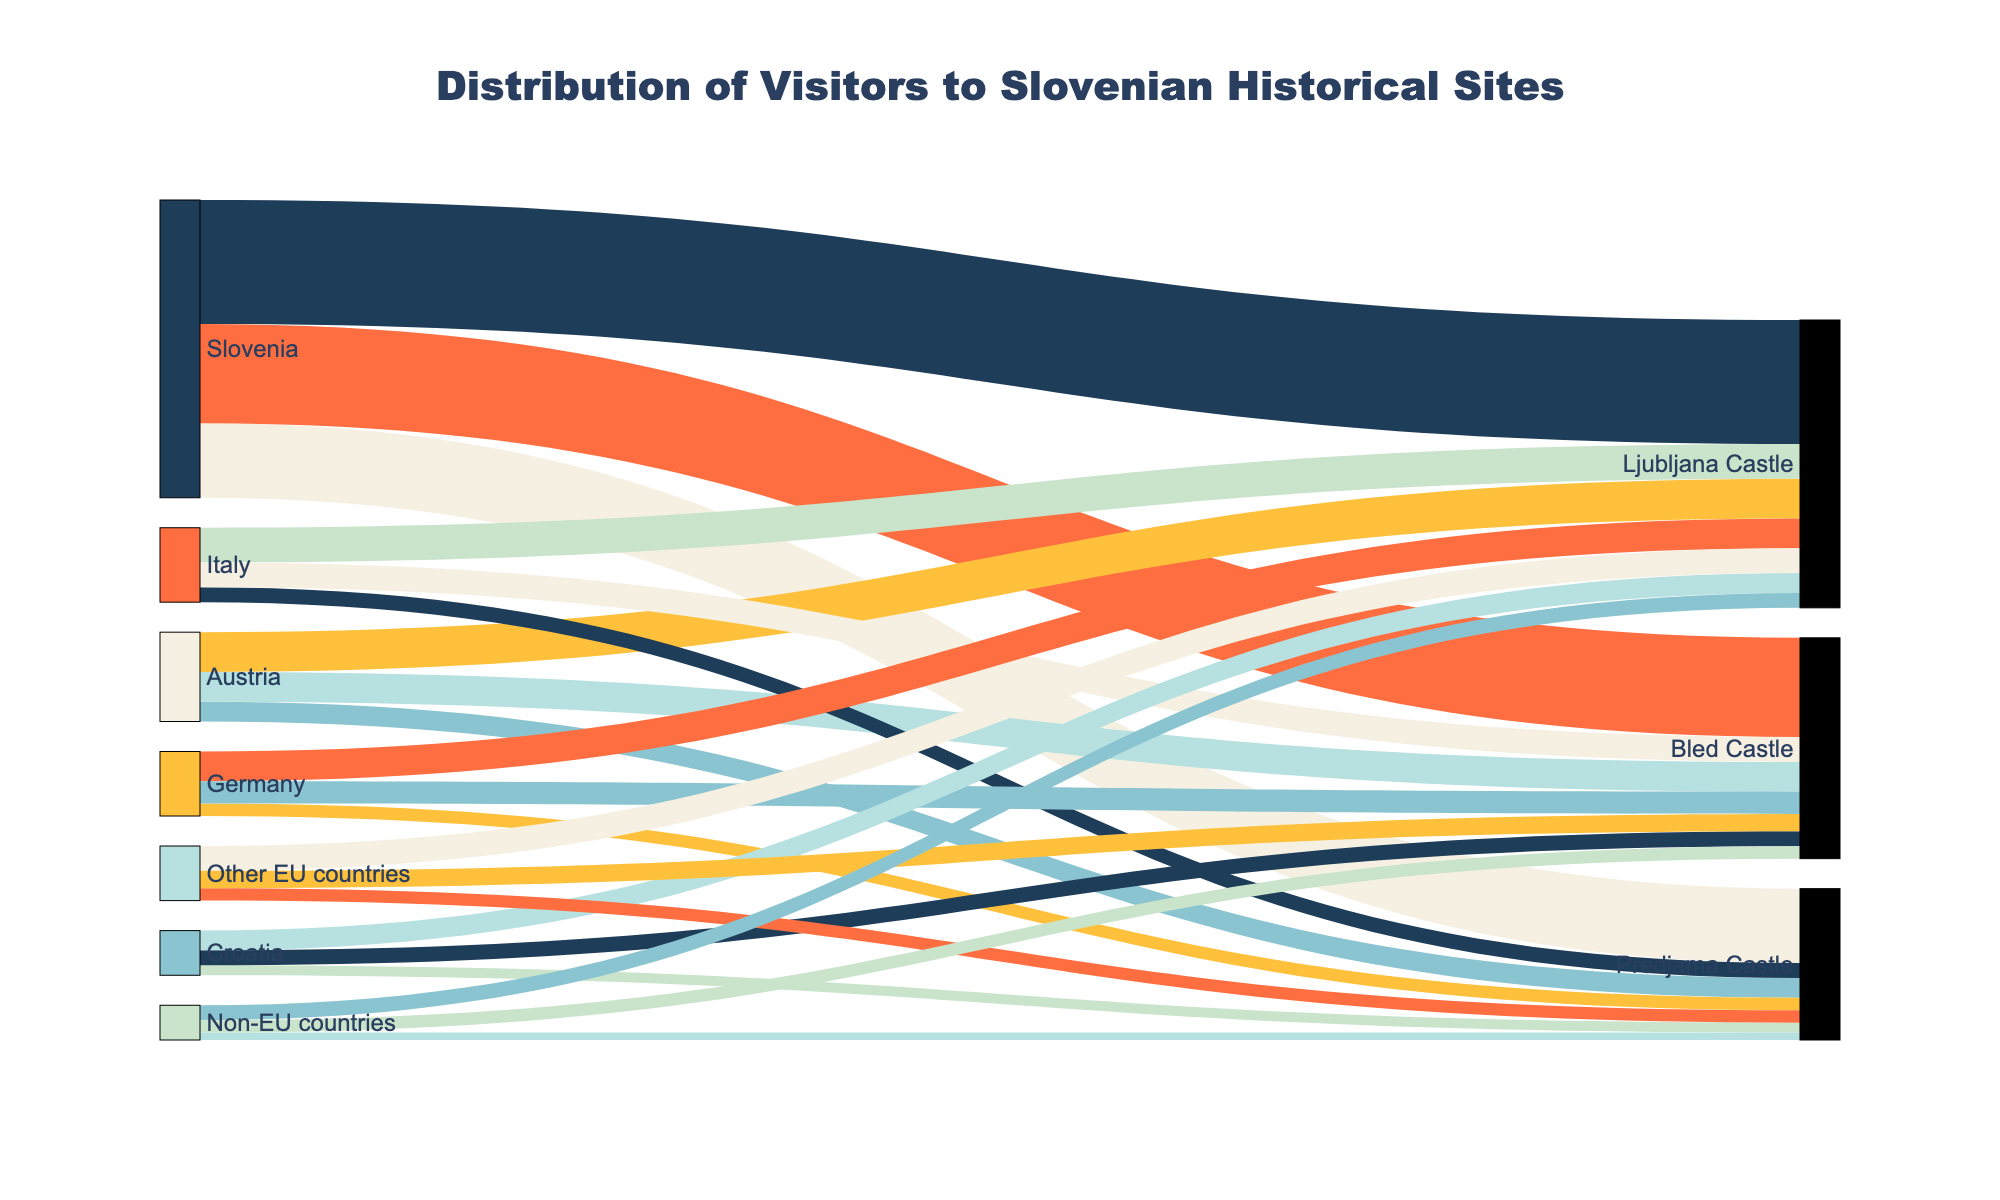what is the main title of the figure? The main title of the figure is usually found at the top of the chart and describes the overall theme or purpose of the visualization. In this case, it is "Distribution of Visitors to Slovenian Historical Sites" as indicated in the figure settings.
Answer: Distribution of Visitors to Slovenian Historical Sites what is the total number of visitors from Austria to all Slovenian historical sites in the figure? To find the total number of visitors from Austria, sum the values associated with Austria for all historical sites. These values are 80,000 for Ljubljana Castle, 40,000 for Predjama Castle, and 60,000 for Bled Castle. So, total visitors are 80,000 + 40,000 + 60,000 = 180,000.
Answer: 180,000 which historical site received the most visitors from Slovenia? Look at the values connected between Slovenia and the historical sites. The values are 250,000 for Ljubljana Castle, 150,000 for Predjama Castle, and 200,000 for Bled Castle. Ljubljana Castle has the highest value of 250,000.
Answer: Ljubljana Castle how do the number of visitors to Ljubljana Castle from Non-EU countries compare to those from Germany? Check the values for visitors from Non-EU countries and Germany to Ljubljana Castle. Non-EU countries have 30,000 visitors, while Germany has 60,000 visitors. Compare the two values: 30,000 (Non-EU) is less than 60,000 (Germany).
Answer: Germany has more visitors what is the total number of visitors from all EU countries (excluding Slovenia) to Predjama Castle? First, identify all EU countries excluding Slovenia: Austria, Italy, Germany, Other EU countries. Add the visitors from these regions to Predjama Castle: 40,000 (Austria) + 30,000 (Italy) + 25,000 (Germany) + 25,000 (Other EU countries) = 120,000.
Answer: 120,000 what percentage of the total visitors to Bled Castle are from Slovenia? First, find the total number of visitors to Bled Castle by summing all values for Bled Castle: 200,000 (Slovenia) + 60,000 (Austria) + 50,000 (Italy) + 45,000 (Germany) + 30,000 (Croatia) + 35,000 (Other EU countries) + 25,000 (Non-EU countries) = 445,000. Then, calculate the percentage contributed by Slovenian visitors: (200,000/445,000) * 100 ≈ 44.94%.
Answer: ≈ 44.94% which country contributes the least number of visitors to Slovakian historical sites in total? To find the country with the least number of visitors, sum up the values for each country across all historical sites. The values are: Slovenia: 600,000; Austria: 180,000; Italy: 150,000; Germany: 130,000; Croatia: 90,000; Other EU countries: 110,000; Non-EU countries: 70,000. Non-EU countries have the lowest total.
Answer: Non-EU countries what is the difference in number of visitors between Ljubljana Castle and Predjama Castle from all countries combined? Sum the values for Ljubljana Castle and Predjama Castle and then find the difference. Total visitors for Ljubljana Castle: 250,000 + 80,000 (Austria) + 70,000 (Italy) + 60,000 (Germany) + 40,000 (Croatia) + 50,000 (Other EU countries) + 30,000 (Non-EU countries) = 580,000. Total visitors for Predjama Castle: 150,000 (Slovenia) + 40,000 (Austria) + 30,000 (Italy) + 25,000 (Germany) + 20,000 (Croatia) + 25,000 (Other EU countries) + 15,000 (Non-EU countries) = 305,000. Difference: 580,000 - 305,000 = 275,000.
Answer: 275,000 which historical site has the most diverse visitor origin, based on the number of different countries from which visitors come? Count the number of different countries sending visitors to each site. All sites have visitors from all listed countries, making them equally diverse in terms of visitor origin. All three sites - Ljubljana Castle, Predjama Castle, and Bled Castle - have visitors from Slovenia, Austria, Italy, Germany, Croatia, Other EU countries, and Non-EU countries, summing to 7.
Answer: All three sites 